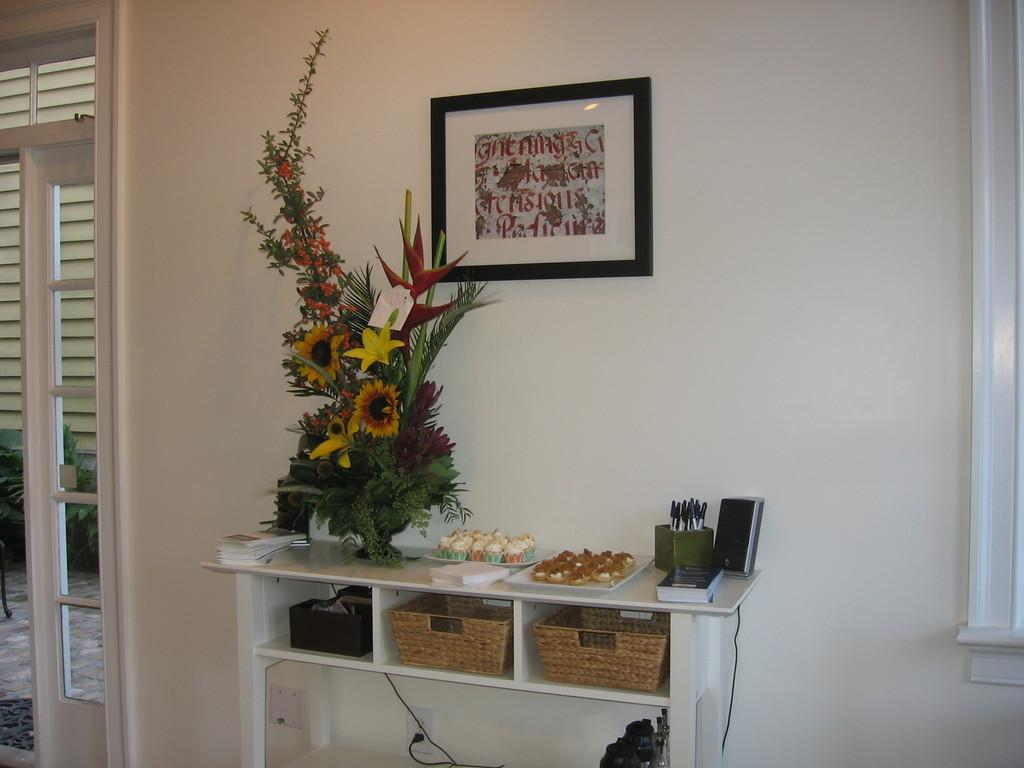What is the color of the wall in the image? The wall in the image is white. What can be seen hanging on the wall? There is a photo frame in the image. What architectural feature is present in the image? There is a door in the image. What type of decorative item is visible in the image? There is a bouquet in the image. What type of popcorn is being served in the field in the image? There is no popcorn or field present in the image. 